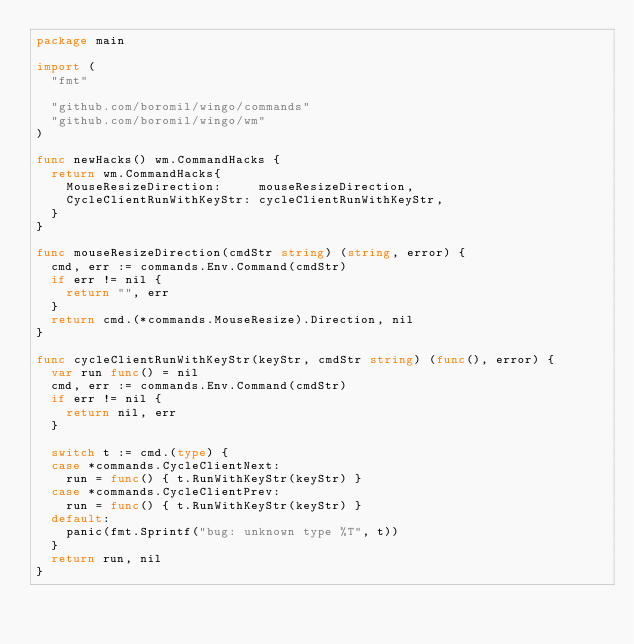Convert code to text. <code><loc_0><loc_0><loc_500><loc_500><_Go_>package main

import (
	"fmt"

	"github.com/boromil/wingo/commands"
	"github.com/boromil/wingo/wm"
)

func newHacks() wm.CommandHacks {
	return wm.CommandHacks{
		MouseResizeDirection:     mouseResizeDirection,
		CycleClientRunWithKeyStr: cycleClientRunWithKeyStr,
	}
}

func mouseResizeDirection(cmdStr string) (string, error) {
	cmd, err := commands.Env.Command(cmdStr)
	if err != nil {
		return "", err
	}
	return cmd.(*commands.MouseResize).Direction, nil
}

func cycleClientRunWithKeyStr(keyStr, cmdStr string) (func(), error) {
	var run func() = nil
	cmd, err := commands.Env.Command(cmdStr)
	if err != nil {
		return nil, err
	}

	switch t := cmd.(type) {
	case *commands.CycleClientNext:
		run = func() { t.RunWithKeyStr(keyStr) }
	case *commands.CycleClientPrev:
		run = func() { t.RunWithKeyStr(keyStr) }
	default:
		panic(fmt.Sprintf("bug: unknown type %T", t))
	}
	return run, nil
}
</code> 